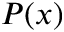Convert formula to latex. <formula><loc_0><loc_0><loc_500><loc_500>P ( x )</formula> 